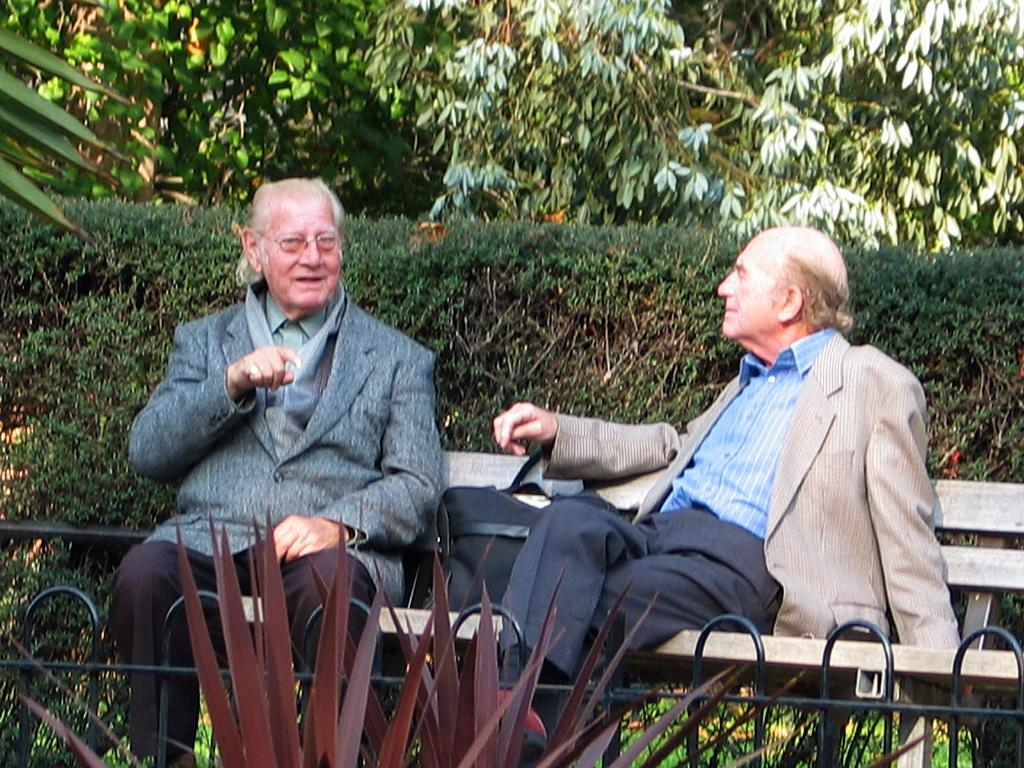How many people are sitting on the bench in the image? There are two people sitting on the bench in the image. What else is on the bench besides the people? There is a bag on the bench. What can be seen in the background of the image? There are trees in the background of the image. What architectural feature is present in the image? There is a fence in the image. Is the bench sinking into the quicksand in the image? There is no quicksand present in the image, and the bench is not sinking. What type of pen is being used by one of the people sitting on the bench? There is no pen visible in the image, and neither person is holding or using a pen. 